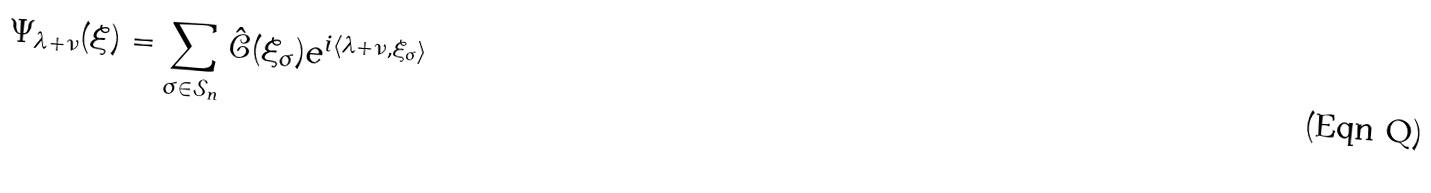Convert formula to latex. <formula><loc_0><loc_0><loc_500><loc_500>\Psi _ { \lambda + \nu } ( \xi ) = \sum _ { \sigma \in \mathcal { S } _ { n } } \hat { \mathcal { C } } ( \xi _ { \sigma } ) e ^ { i \langle \lambda + \nu , \xi _ { \sigma } \rangle }</formula> 